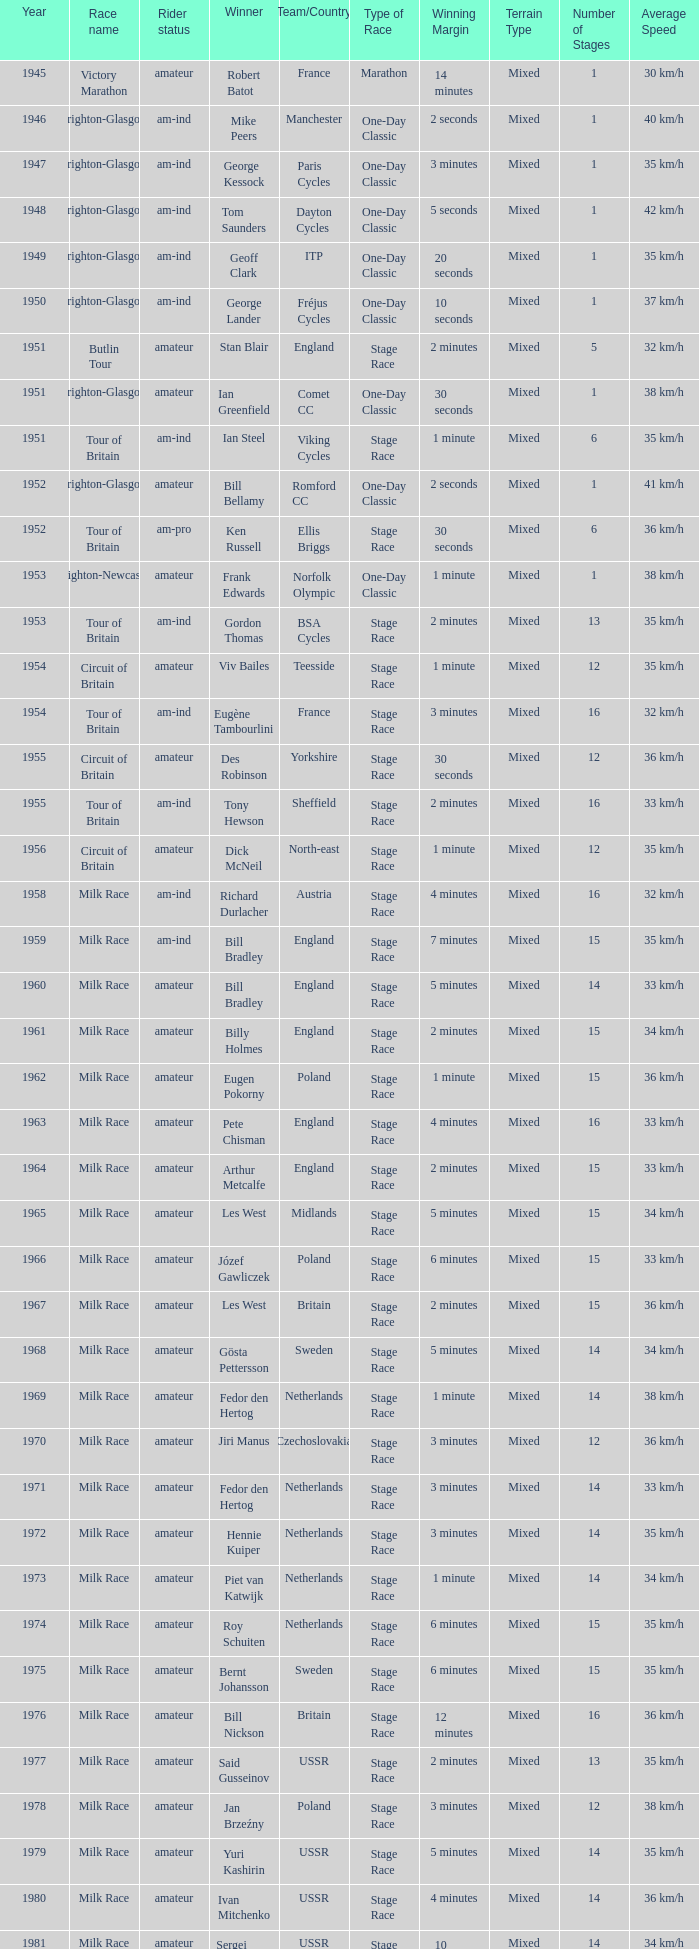What ream played later than 1958 in the kellogg's tour? ANC, Fagor, Z-Peugeot, Weinnmann-SMM, Motorola, Motorola, Motorola, Lampre. 